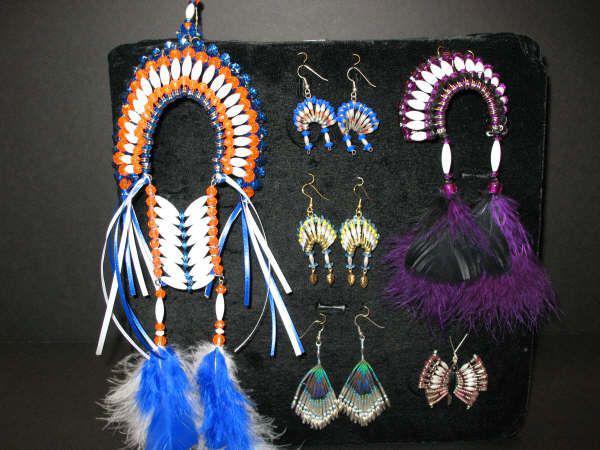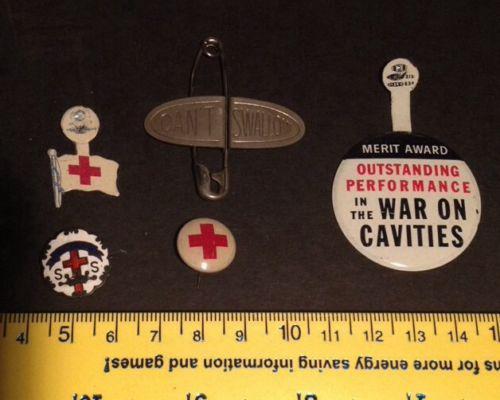The first image is the image on the left, the second image is the image on the right. Examine the images to the left and right. Is the description "There is a bracelet in the image on the left." accurate? Answer yes or no. No. The first image is the image on the left, the second image is the image on the right. For the images displayed, is the sentence "One image shows one bracelet made of beaded safety pins." factually correct? Answer yes or no. No. 